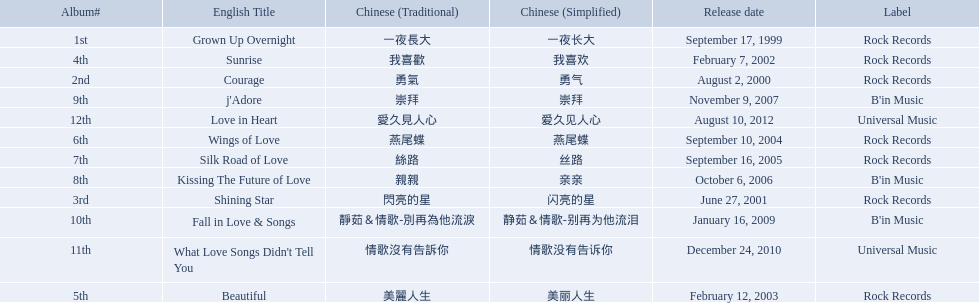What were the albums? Grown Up Overnight, Courage, Shining Star, Sunrise, Beautiful, Wings of Love, Silk Road of Love, Kissing The Future of Love, j'Adore, Fall in Love & Songs, What Love Songs Didn't Tell You, Love in Heart. Which ones were released by b'in music? Kissing The Future of Love, j'Adore. Parse the full table in json format. {'header': ['Album#', 'English Title', 'Chinese (Traditional)', 'Chinese (Simplified)', 'Release date', 'Label'], 'rows': [['1st', 'Grown Up Overnight', '一夜長大', '一夜长大', 'September 17, 1999', 'Rock Records'], ['4th', 'Sunrise', '我喜歡', '我喜欢', 'February 7, 2002', 'Rock Records'], ['2nd', 'Courage', '勇氣', '勇气', 'August 2, 2000', 'Rock Records'], ['9th', "j'Adore", '崇拜', '崇拜', 'November 9, 2007', "B'in Music"], ['12th', 'Love in Heart', '愛久見人心', '爱久见人心', 'August 10, 2012', 'Universal Music'], ['6th', 'Wings of Love', '燕尾蝶', '燕尾蝶', 'September 10, 2004', 'Rock Records'], ['7th', 'Silk Road of Love', '絲路', '丝路', 'September 16, 2005', 'Rock Records'], ['8th', 'Kissing The Future of Love', '親親', '亲亲', 'October 6, 2006', "B'in Music"], ['3rd', 'Shining Star', '閃亮的星', '闪亮的星', 'June 27, 2001', 'Rock Records'], ['10th', 'Fall in Love & Songs', '靜茹＆情歌-別再為他流淚', '静茹＆情歌-别再为他流泪', 'January 16, 2009', "B'in Music"], ['11th', "What Love Songs Didn't Tell You", '情歌沒有告訴你', '情歌没有告诉你', 'December 24, 2010', 'Universal Music'], ['5th', 'Beautiful', '美麗人生', '美丽人生', 'February 12, 2003', 'Rock Records']]} Of these, which one was in an even-numbered year? Kissing The Future of Love. 